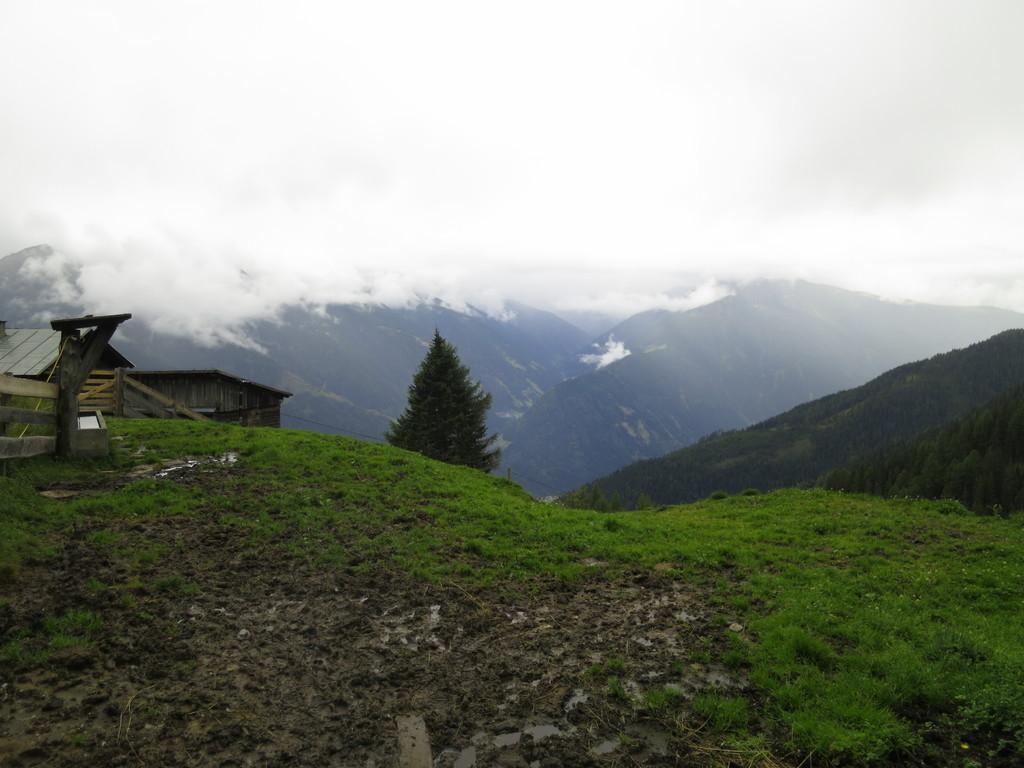How would you summarize this image in a sentence or two? In this picture we can see grass at the bottom, in the background we can see trees and hills, on the left side there is a house, we can see the cloudy sky at the top of the picture. 